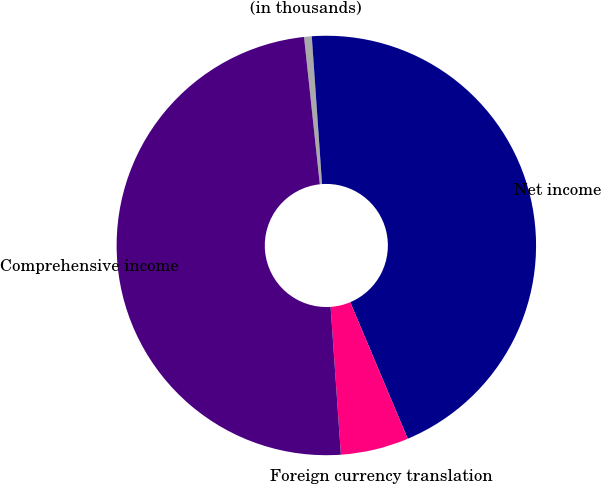Convert chart. <chart><loc_0><loc_0><loc_500><loc_500><pie_chart><fcel>(in thousands)<fcel>Net income<fcel>Foreign currency translation<fcel>Comprehensive income<nl><fcel>0.59%<fcel>44.76%<fcel>5.24%<fcel>49.41%<nl></chart> 